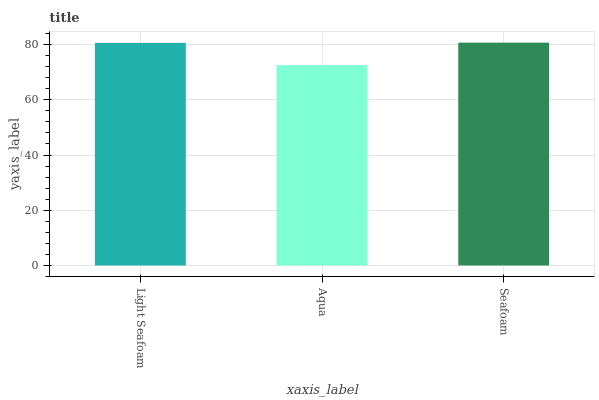Is Aqua the minimum?
Answer yes or no. Yes. Is Seafoam the maximum?
Answer yes or no. Yes. Is Seafoam the minimum?
Answer yes or no. No. Is Aqua the maximum?
Answer yes or no. No. Is Seafoam greater than Aqua?
Answer yes or no. Yes. Is Aqua less than Seafoam?
Answer yes or no. Yes. Is Aqua greater than Seafoam?
Answer yes or no. No. Is Seafoam less than Aqua?
Answer yes or no. No. Is Light Seafoam the high median?
Answer yes or no. Yes. Is Light Seafoam the low median?
Answer yes or no. Yes. Is Aqua the high median?
Answer yes or no. No. Is Aqua the low median?
Answer yes or no. No. 